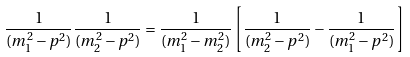<formula> <loc_0><loc_0><loc_500><loc_500>\frac { 1 } { ( m _ { 1 } ^ { 2 } - p ^ { 2 } ) } \frac { 1 } { ( m _ { 2 } ^ { 2 } - p ^ { 2 } ) } = \frac { 1 } { ( m _ { 1 } ^ { 2 } - m _ { 2 } ^ { 2 } ) } \left [ \frac { 1 } { ( m _ { 2 } ^ { 2 } - p ^ { 2 } ) } - \frac { 1 } { ( m _ { 1 } ^ { 2 } - p ^ { 2 } ) } \right ]</formula> 